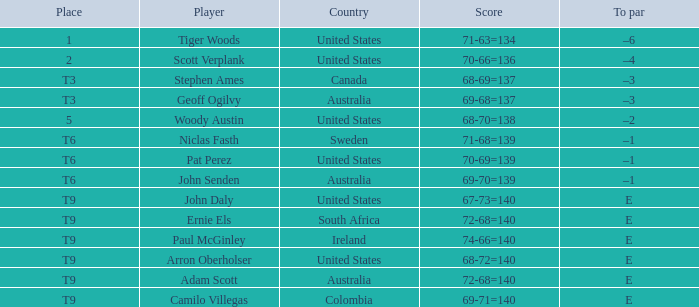What is the point total for canada? 68-69=137. 